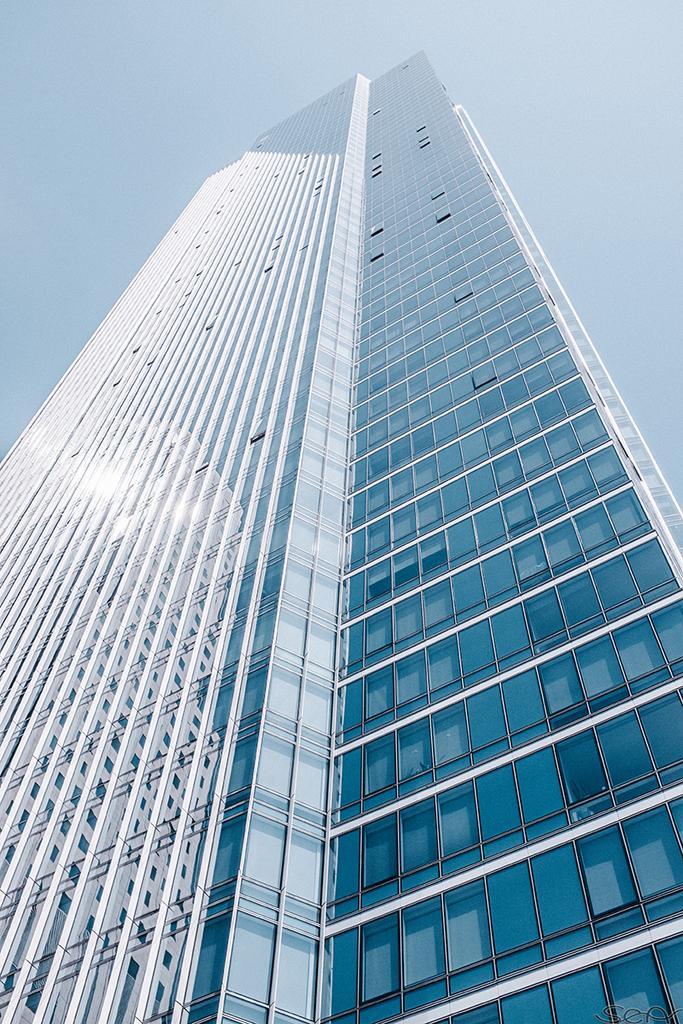In one or two sentences, can you explain what this image depicts? This is building, this is sky. 